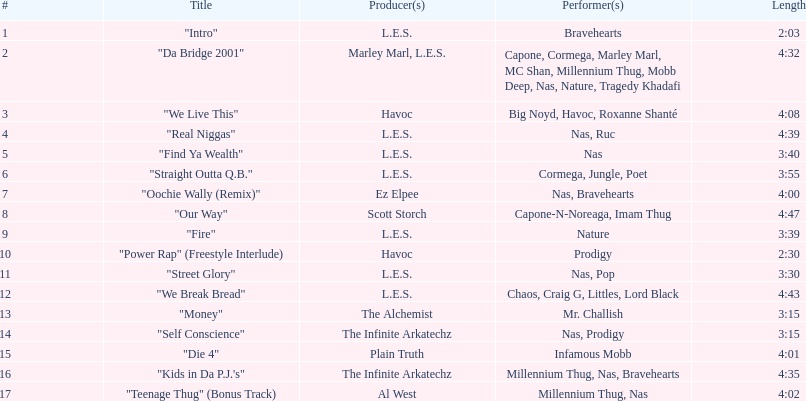After street glory, what track is featured? "We Break Bread". 